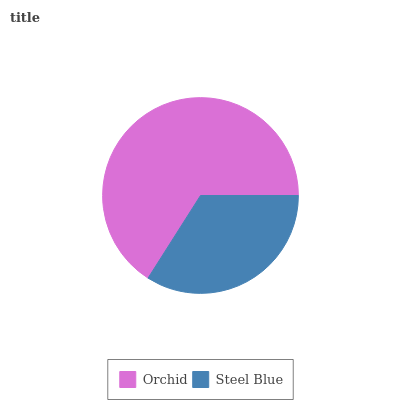Is Steel Blue the minimum?
Answer yes or no. Yes. Is Orchid the maximum?
Answer yes or no. Yes. Is Steel Blue the maximum?
Answer yes or no. No. Is Orchid greater than Steel Blue?
Answer yes or no. Yes. Is Steel Blue less than Orchid?
Answer yes or no. Yes. Is Steel Blue greater than Orchid?
Answer yes or no. No. Is Orchid less than Steel Blue?
Answer yes or no. No. Is Orchid the high median?
Answer yes or no. Yes. Is Steel Blue the low median?
Answer yes or no. Yes. Is Steel Blue the high median?
Answer yes or no. No. Is Orchid the low median?
Answer yes or no. No. 